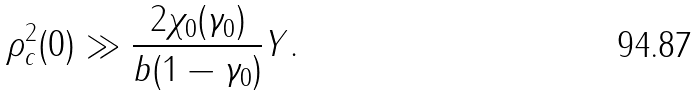<formula> <loc_0><loc_0><loc_500><loc_500>\rho _ { c } ^ { 2 } ( 0 ) \gg \frac { 2 \chi _ { 0 } ( \gamma _ { 0 } ) } { b ( 1 - \gamma _ { 0 } ) } Y .</formula> 